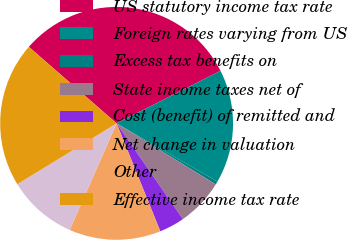Convert chart to OTSL. <chart><loc_0><loc_0><loc_500><loc_500><pie_chart><fcel>US statutory income tax rate<fcel>Foreign rates varying from US<fcel>Excess tax benefits on<fcel>State income taxes net of<fcel>Cost (benefit) of remitted and<fcel>Net change in valuation<fcel>Other<fcel>Effective income tax rate<nl><fcel>31.13%<fcel>15.79%<fcel>0.44%<fcel>6.58%<fcel>3.51%<fcel>12.72%<fcel>9.65%<fcel>20.16%<nl></chart> 